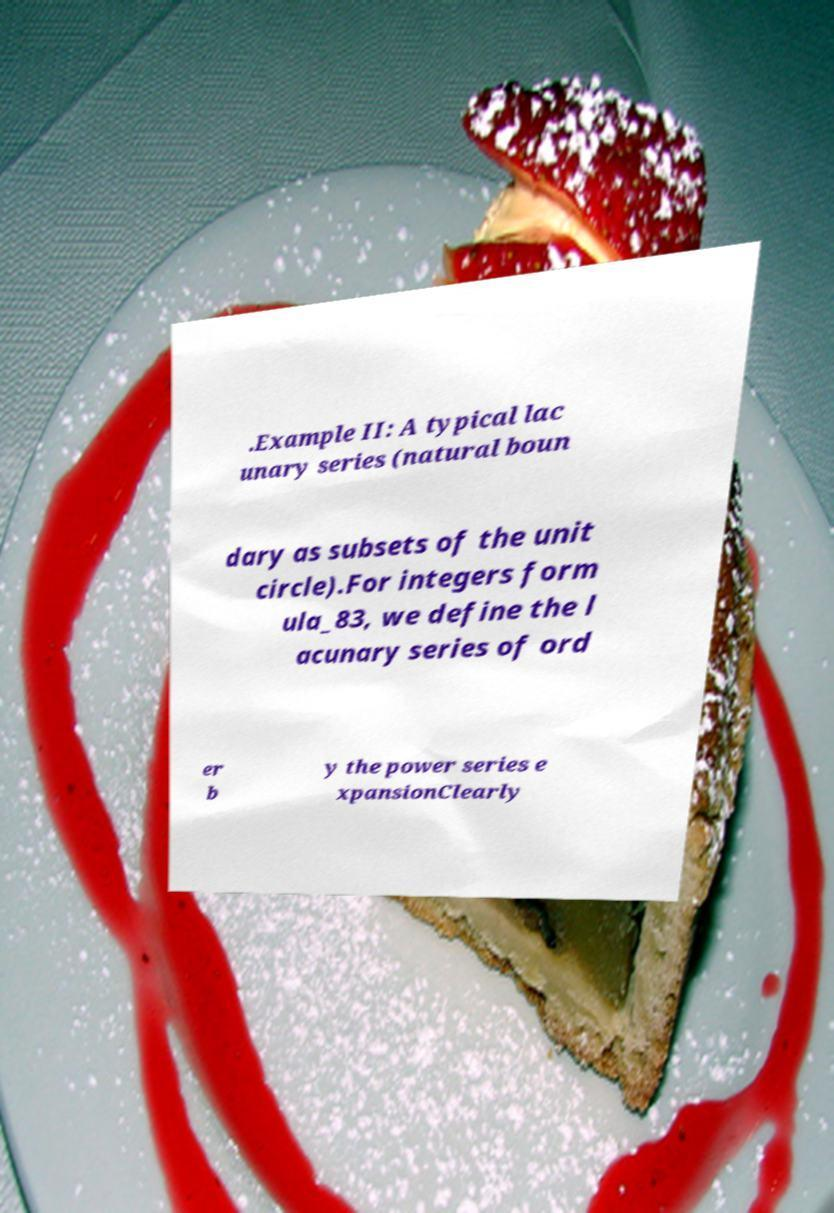What messages or text are displayed in this image? I need them in a readable, typed format. .Example II: A typical lac unary series (natural boun dary as subsets of the unit circle).For integers form ula_83, we define the l acunary series of ord er b y the power series e xpansionClearly 